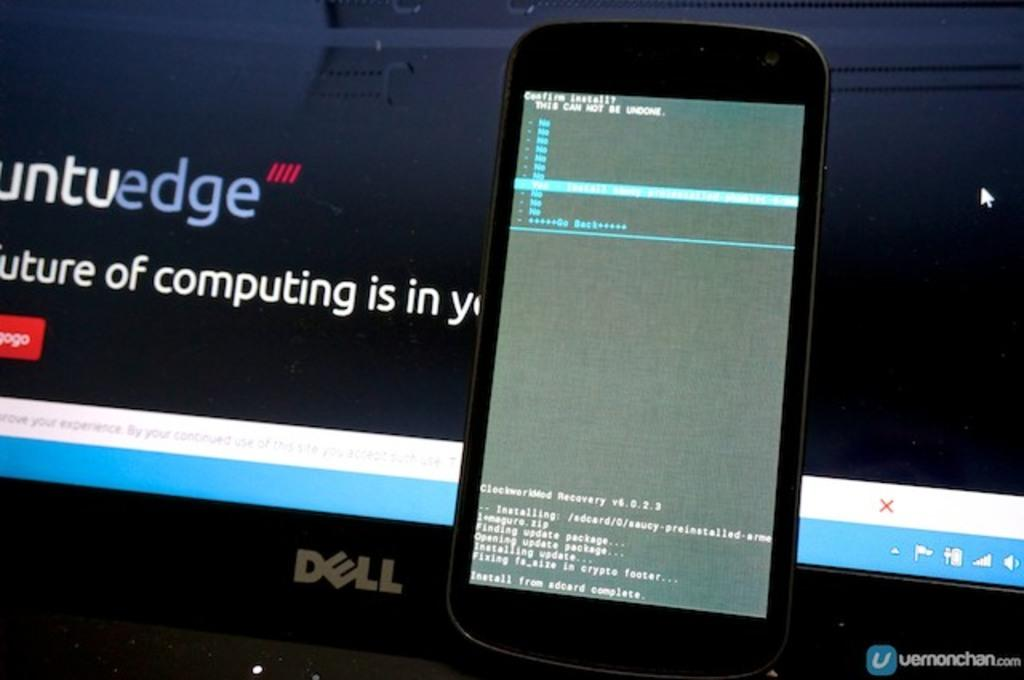What is the main object in the image? There is a mobile in the image. Where is the mobile located? The mobile is on a laptop. What else can be seen in the image? There is a screen visible in the background of the image. What type of hall can be seen in the image? There is no hall present in the image; it features a mobile on a laptop with a screen in the background. Is there a camera visible in the image? There is no camera visible in the image. 